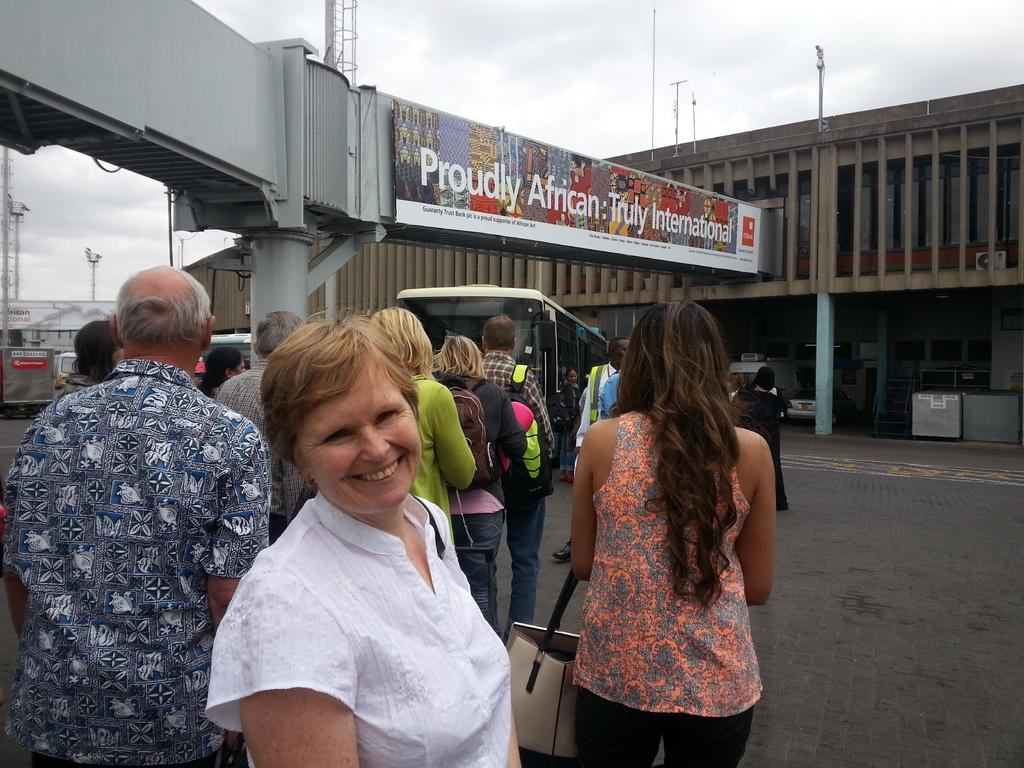What are the people in the image doing? There is a group of people standing on the ground in the image. What can be seen in the background of the image? There are vehicles parked, metal frames, buildings, and the sky visible in the background. How many clocks are hanging on the walls of the buildings in the image? There is no information about clocks or walls of buildings in the image, so it cannot be determined. What type of religious symbol can be seen on the table in the image? There is no table or religious symbol present in the image. 